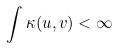<formula> <loc_0><loc_0><loc_500><loc_500>\int { \kappa ( u , v ) } < \infty</formula> 